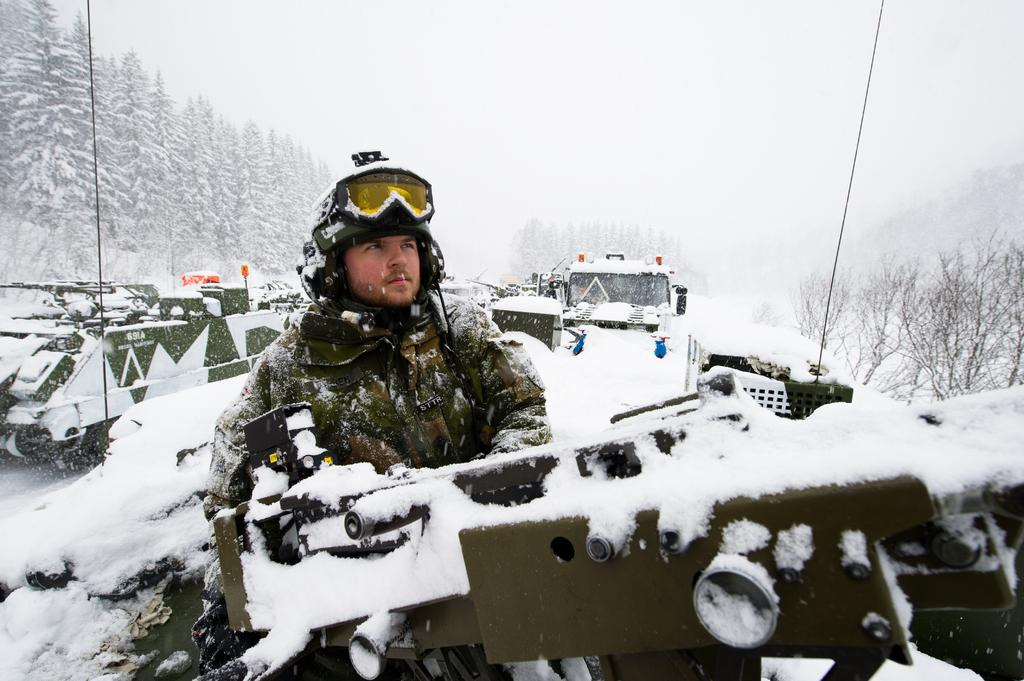What type of vehicles can be seen in the image? There are tanks in the image. Can you describe the man in the image? The man is wearing a uniform and a helmet. What is visible in the background of the image? There are trees, snow, and the sky visible in the background of the image. What type of berry is being used to fuel the tanks in the image? There is no berry present in the image, and berries are not used to fuel tanks. 